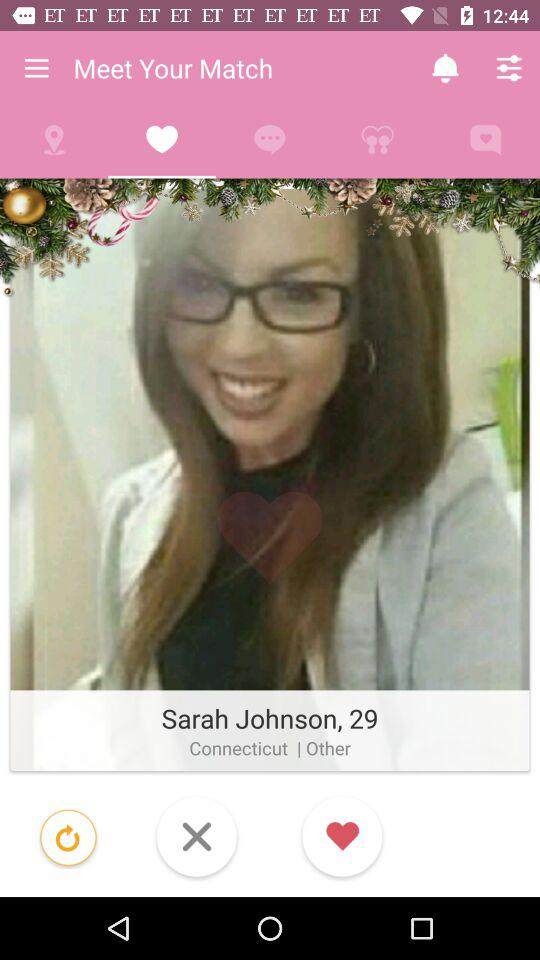Which tab is selected? The selected tab is "Favorites". 